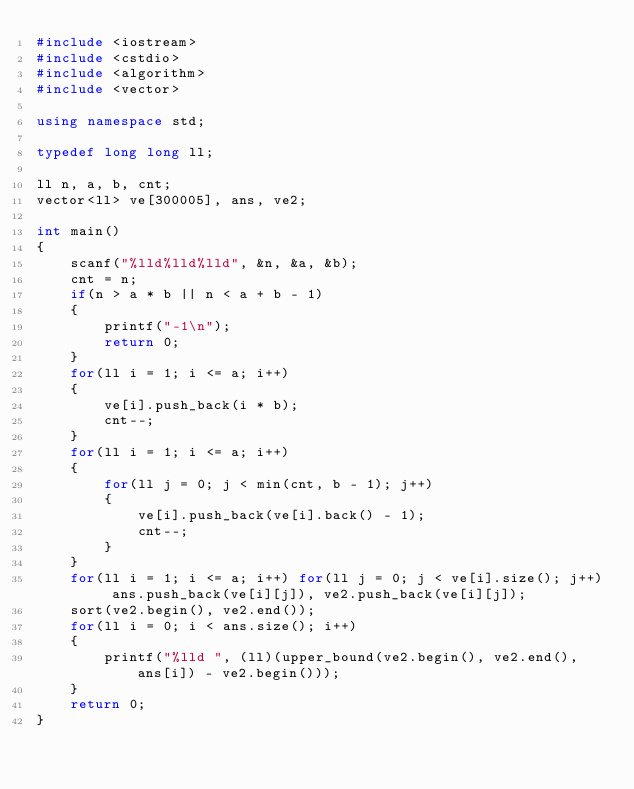<code> <loc_0><loc_0><loc_500><loc_500><_C++_>#include <iostream>
#include <cstdio>
#include <algorithm>
#include <vector>

using namespace std;

typedef long long ll;

ll n, a, b, cnt;
vector<ll> ve[300005], ans, ve2;

int main()
{
    scanf("%lld%lld%lld", &n, &a, &b);
    cnt = n;
    if(n > a * b || n < a + b - 1)
    {
        printf("-1\n");
        return 0;
    }
    for(ll i = 1; i <= a; i++)
    {
        ve[i].push_back(i * b);
        cnt--;
    }
    for(ll i = 1; i <= a; i++)
    {
        for(ll j = 0; j < min(cnt, b - 1); j++)
        {
            ve[i].push_back(ve[i].back() - 1);
            cnt--;
        }
    }
    for(ll i = 1; i <= a; i++) for(ll j = 0; j < ve[i].size(); j++) ans.push_back(ve[i][j]), ve2.push_back(ve[i][j]);
    sort(ve2.begin(), ve2.end());
    for(ll i = 0; i < ans.size(); i++)
    {
        printf("%lld ", (ll)(upper_bound(ve2.begin(), ve2.end(), ans[i]) - ve2.begin()));
    }
    return 0;
}
</code> 